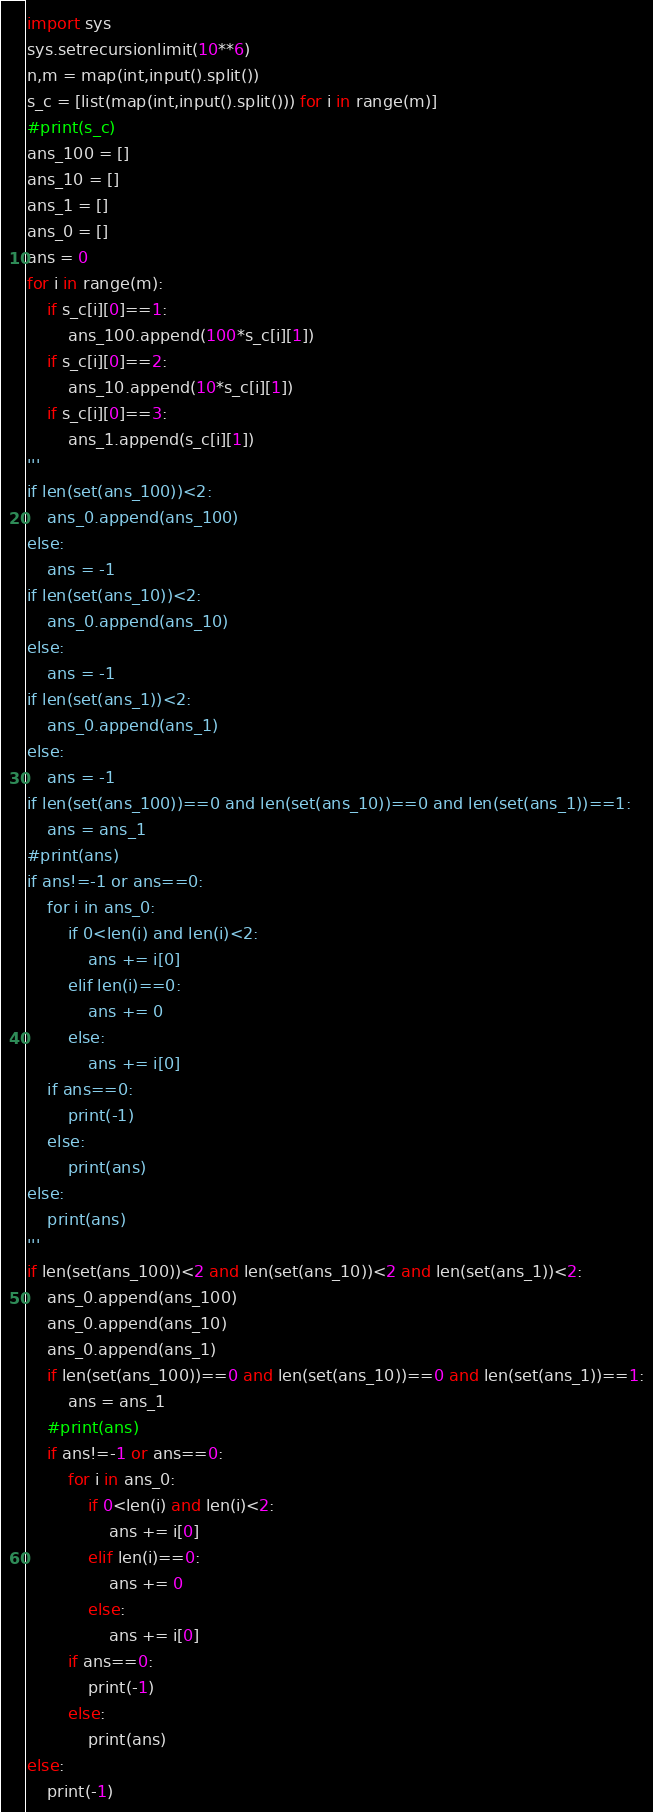Convert code to text. <code><loc_0><loc_0><loc_500><loc_500><_Python_>
import sys
sys.setrecursionlimit(10**6)
n,m = map(int,input().split())
s_c = [list(map(int,input().split())) for i in range(m)]
#print(s_c)
ans_100 = []
ans_10 = []
ans_1 = []
ans_0 = []
ans = 0
for i in range(m):
    if s_c[i][0]==1:
        ans_100.append(100*s_c[i][1])
    if s_c[i][0]==2:
        ans_10.append(10*s_c[i][1])
    if s_c[i][0]==3:
        ans_1.append(s_c[i][1])
'''
if len(set(ans_100))<2:
    ans_0.append(ans_100)
else:
    ans = -1
if len(set(ans_10))<2:
    ans_0.append(ans_10)
else:
    ans = -1
if len(set(ans_1))<2:
    ans_0.append(ans_1)
else:
    ans = -1
if len(set(ans_100))==0 and len(set(ans_10))==0 and len(set(ans_1))==1:
    ans = ans_1
#print(ans)
if ans!=-1 or ans==0:
    for i in ans_0:
        if 0<len(i) and len(i)<2:
            ans += i[0]
        elif len(i)==0:
            ans += 0
        else:
            ans += i[0]
    if ans==0:
        print(-1)
    else:
        print(ans)
else:
    print(ans)
'''
if len(set(ans_100))<2 and len(set(ans_10))<2 and len(set(ans_1))<2:
    ans_0.append(ans_100)
    ans_0.append(ans_10)
    ans_0.append(ans_1)
    if len(set(ans_100))==0 and len(set(ans_10))==0 and len(set(ans_1))==1:
        ans = ans_1
    #print(ans)
    if ans!=-1 or ans==0:
        for i in ans_0:
            if 0<len(i) and len(i)<2:
                ans += i[0]
            elif len(i)==0:
                ans += 0
            else:
                ans += i[0]
        if ans==0:
            print(-1)
        else:
            print(ans)
else:
    print(-1)</code> 